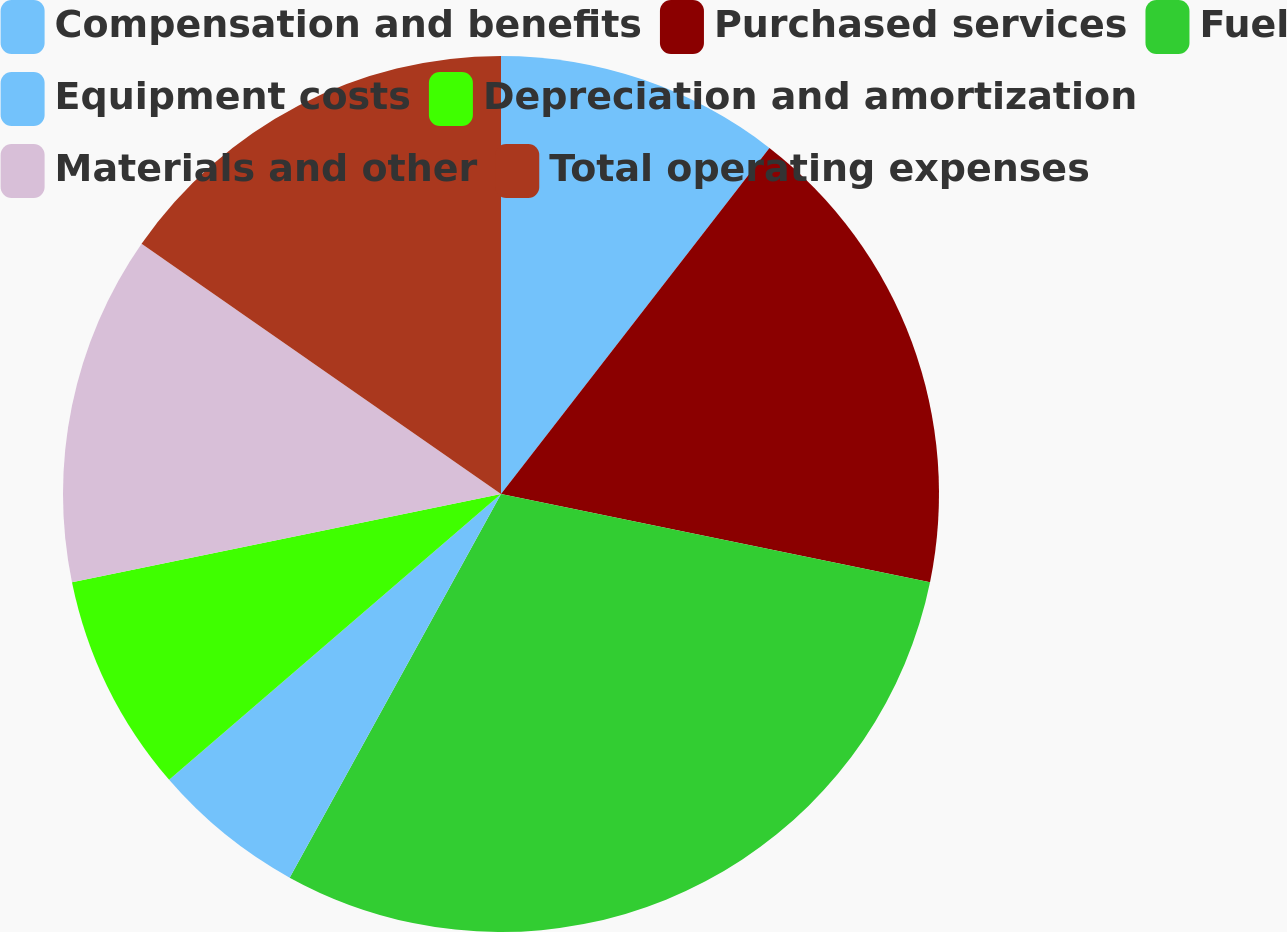<chart> <loc_0><loc_0><loc_500><loc_500><pie_chart><fcel>Compensation and benefits<fcel>Purchased services<fcel>Fuel<fcel>Equipment costs<fcel>Depreciation and amortization<fcel>Materials and other<fcel>Total operating expenses<nl><fcel>10.5%<fcel>17.73%<fcel>29.79%<fcel>5.67%<fcel>8.09%<fcel>12.91%<fcel>15.32%<nl></chart> 